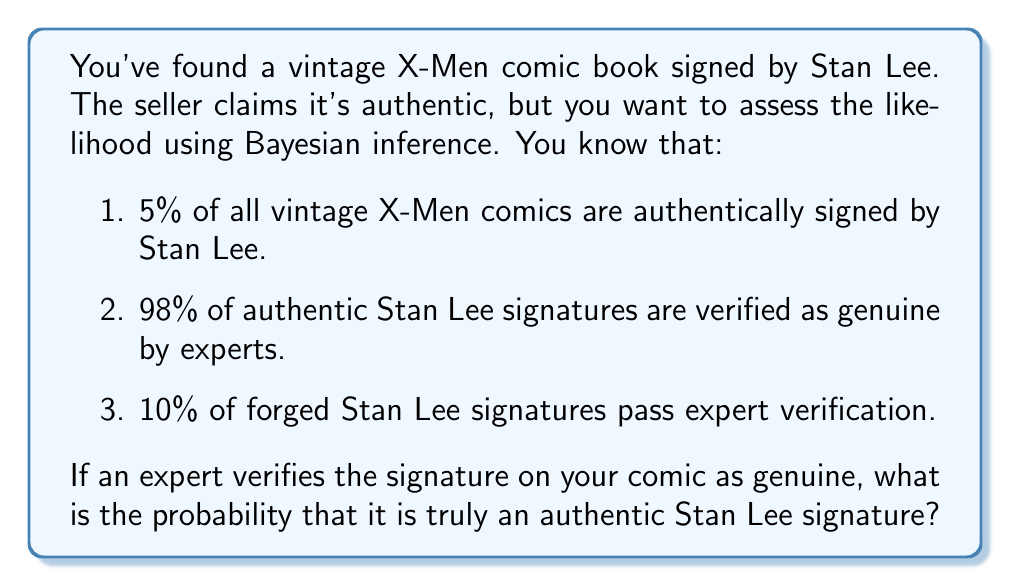Solve this math problem. Let's approach this problem using Bayesian inference:

1. Define our events:
   A: The comic has an authentic Stan Lee signature
   V: The signature is verified as genuine by an expert

2. Given probabilities:
   P(A) = 0.05 (prior probability of authenticity)
   P(V|A) = 0.98 (probability of verification given authenticity)
   P(V|not A) = 0.10 (probability of verification given forgery)

3. We want to find P(A|V) using Bayes' theorem:

   $$P(A|V) = \frac{P(V|A) \cdot P(A)}{P(V)}$$

4. Calculate P(V) using the law of total probability:
   
   $$P(V) = P(V|A) \cdot P(A) + P(V|not A) \cdot P(not A)$$
   $$P(V) = 0.98 \cdot 0.05 + 0.10 \cdot 0.95$$
   $$P(V) = 0.049 + 0.095 = 0.144$$

5. Now we can apply Bayes' theorem:

   $$P(A|V) = \frac{0.98 \cdot 0.05}{0.144}$$
   $$P(A|V) = \frac{0.049}{0.144} \approx 0.3403$$

6. Convert to a percentage:
   0.3403 * 100 ≈ 34.03%

Therefore, if an expert verifies the signature as genuine, there is approximately a 34.03% chance that it is truly an authentic Stan Lee signature.
Answer: 34.03% 